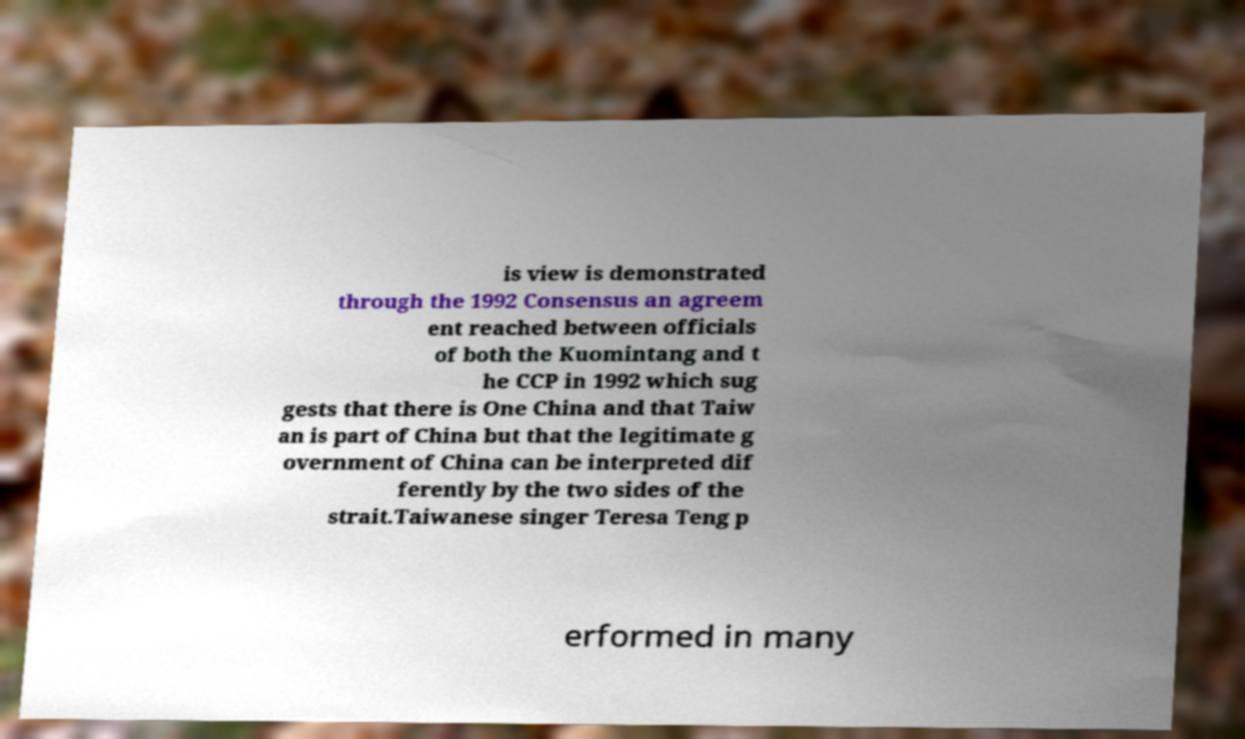Can you accurately transcribe the text from the provided image for me? is view is demonstrated through the 1992 Consensus an agreem ent reached between officials of both the Kuomintang and t he CCP in 1992 which sug gests that there is One China and that Taiw an is part of China but that the legitimate g overnment of China can be interpreted dif ferently by the two sides of the strait.Taiwanese singer Teresa Teng p erformed in many 